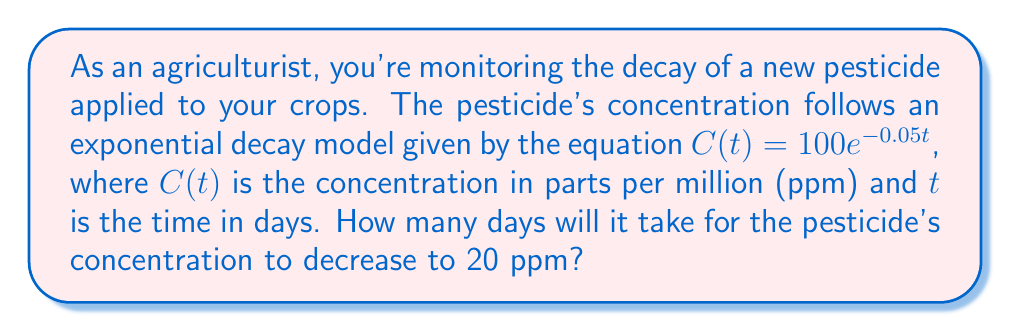Give your solution to this math problem. To solve this problem, we need to use the given exponential decay equation and apply logarithms. Let's approach this step-by-step:

1) We start with the equation: $C(t) = 100e^{-0.05t}$

2) We want to find $t$ when $C(t) = 20$. So, we substitute this:

   $20 = 100e^{-0.05t}$

3) First, divide both sides by 100:

   $\frac{20}{100} = e^{-0.05t}$
   $0.2 = e^{-0.05t}$

4) Now, we take the natural logarithm of both sides. Remember, $\ln(e^x) = x$:

   $\ln(0.2) = \ln(e^{-0.05t})$
   $\ln(0.2) = -0.05t$

5) Solve for $t$ by dividing both sides by -0.05:

   $t = \frac{\ln(0.2)}{-0.05}$

6) Calculate the result:
   $t = \frac{-1.60944...}{-0.05} \approx 32.19$ days

7) Since we're dealing with whole days, we round up to the nearest day.
Answer: It will take 33 days for the pesticide's concentration to decrease to 20 ppm. 